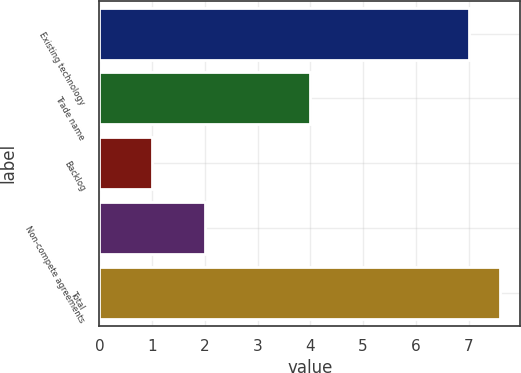Convert chart to OTSL. <chart><loc_0><loc_0><loc_500><loc_500><bar_chart><fcel>Existing technology<fcel>Trade name<fcel>Backlog<fcel>Non-compete agreements<fcel>Total<nl><fcel>7<fcel>4<fcel>1<fcel>2<fcel>7.6<nl></chart> 